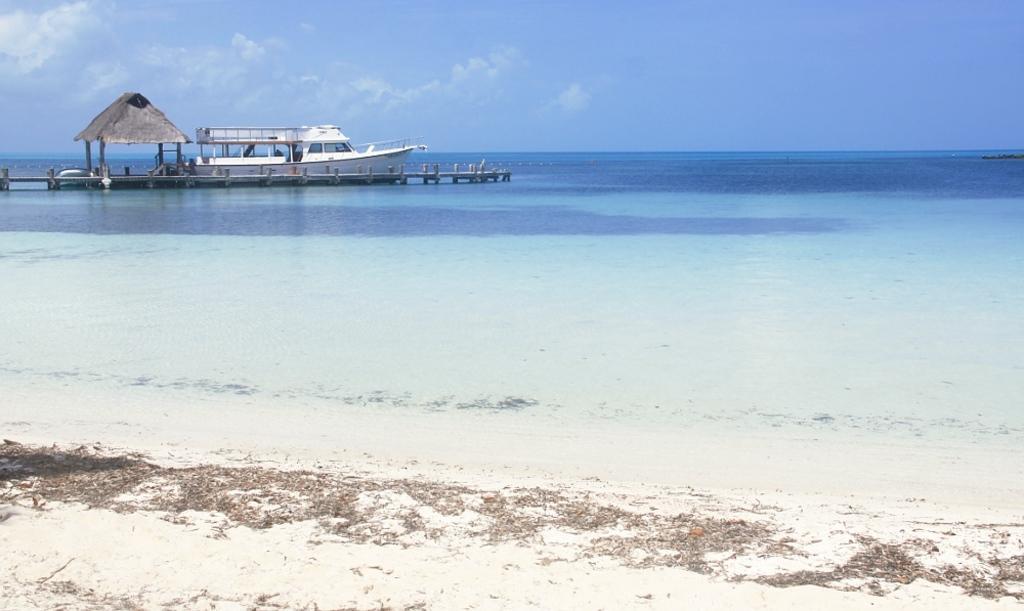Could you give a brief overview of what you see in this image? This image consists of a boat in white color. And we can see a path made up of wood. Beside the boat there is a hut in white color. At the bottom, there is water. In the background, there are clouds in the sky. It looks like it is clicked near the beach. 